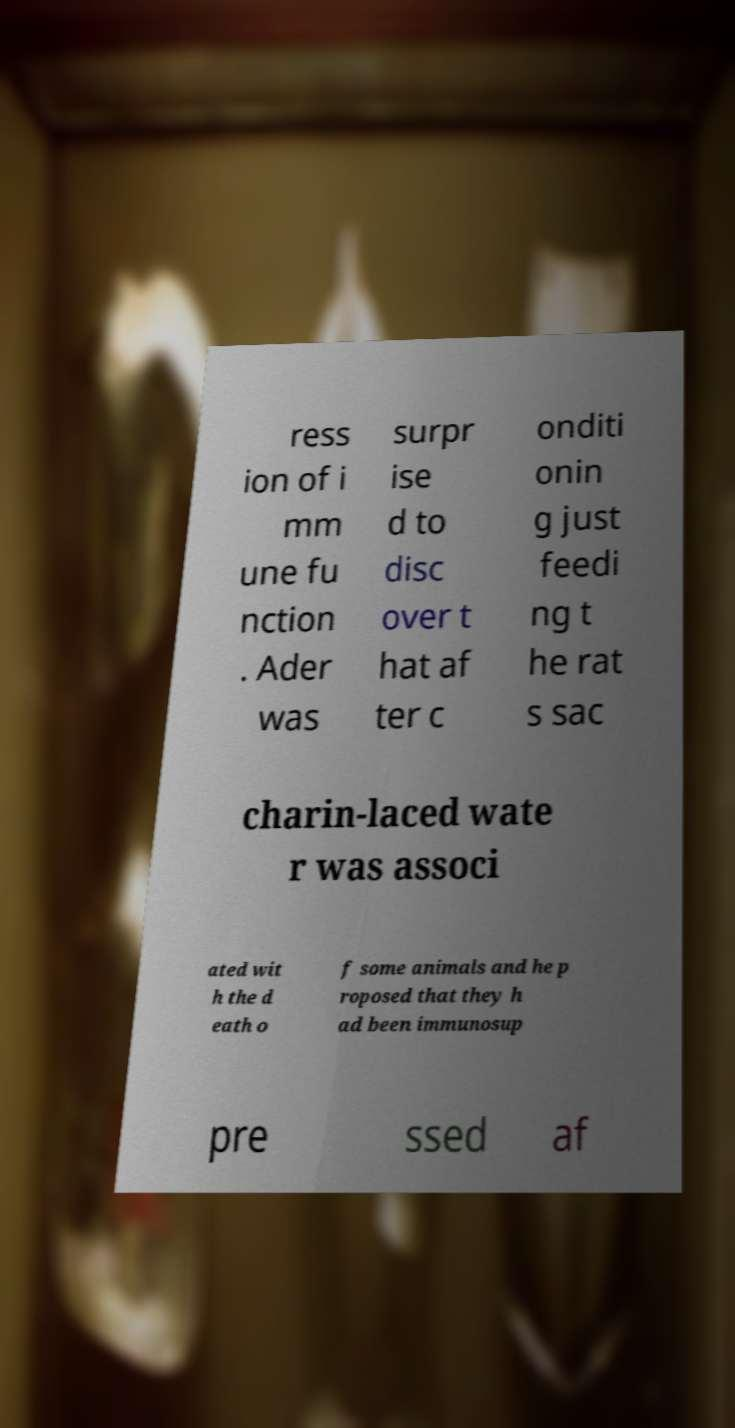There's text embedded in this image that I need extracted. Can you transcribe it verbatim? ress ion of i mm une fu nction . Ader was surpr ise d to disc over t hat af ter c onditi onin g just feedi ng t he rat s sac charin-laced wate r was associ ated wit h the d eath o f some animals and he p roposed that they h ad been immunosup pre ssed af 